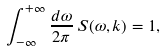<formula> <loc_0><loc_0><loc_500><loc_500>\int _ { - \infty } ^ { + \infty } \frac { d \omega } { 2 \pi } \, S ( \omega , k ) = 1 ,</formula> 